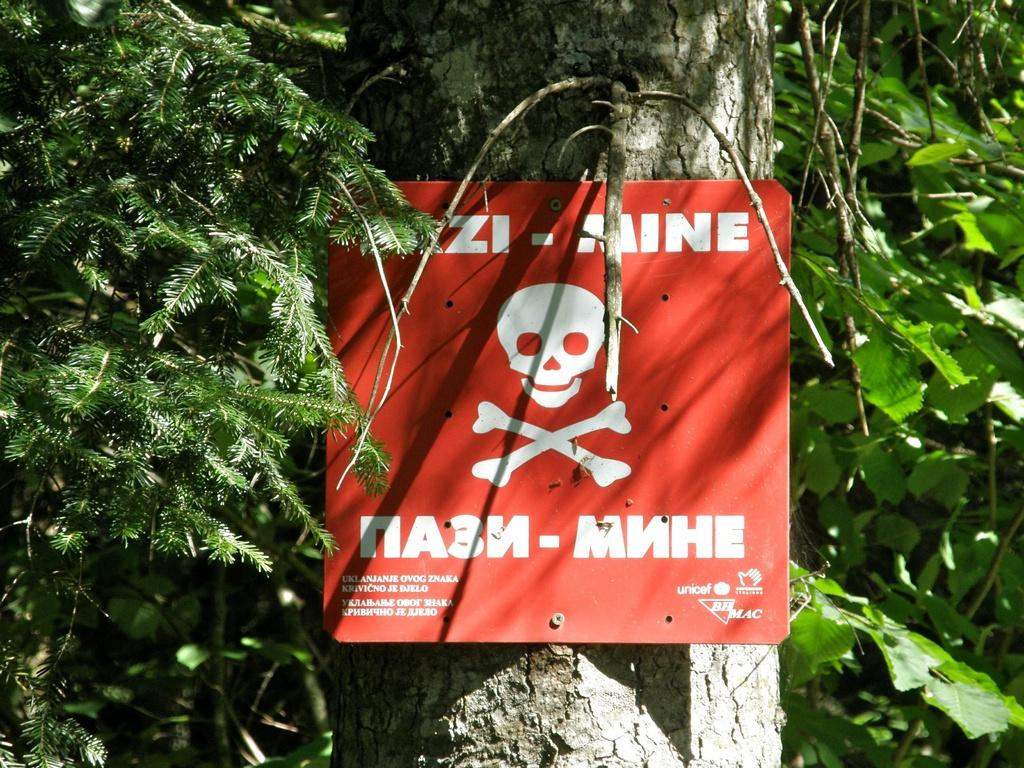What is the main object in the image? There is a sign board in the image. What can be seen in the background of the image? There are trees in the image. What information is displayed on the sign board? There is text visible on the sign board. How many wings are visible on the playground equipment in the image? There is no playground equipment or wings present in the image; it features a sign board with text and trees in the background. 